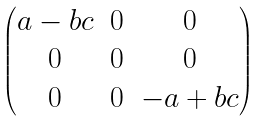Convert formula to latex. <formula><loc_0><loc_0><loc_500><loc_500>\begin{pmatrix} a - b c & 0 & 0 \\ 0 & 0 & 0 \\ 0 & 0 & - a + b c \end{pmatrix}</formula> 